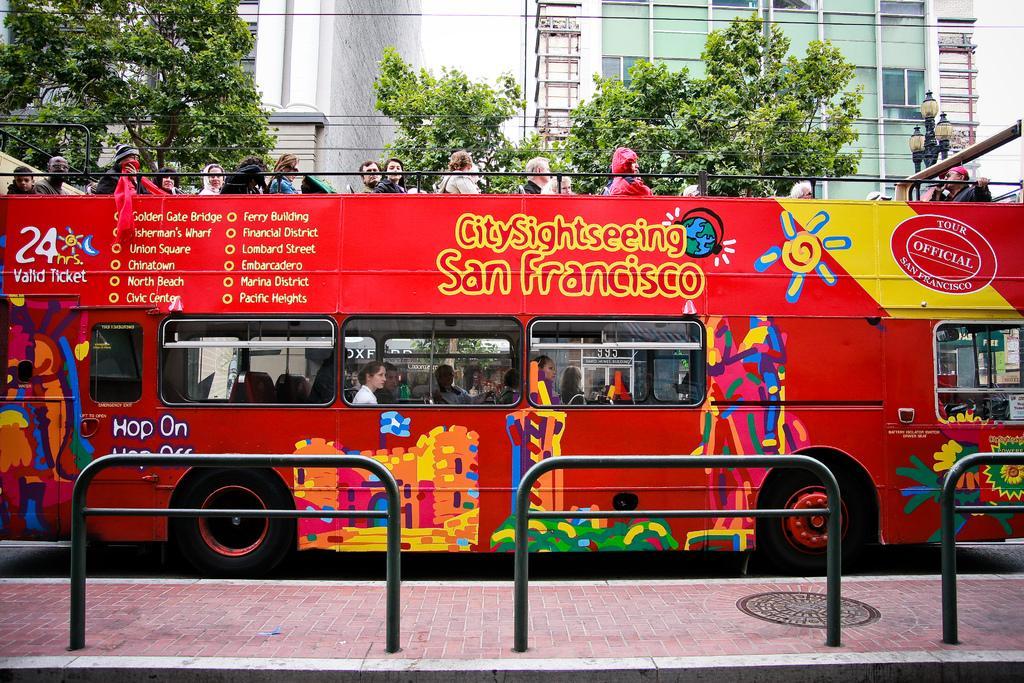How would you summarize this image in a sentence or two? This picture is clicked outside. In the foreground we can see the metal rods and the pavement. In the center there is a red color bus and we can see the group of persons and we can see the text and pictures on the bus. In the background we can see the buildings, lights, poles and the trees. 